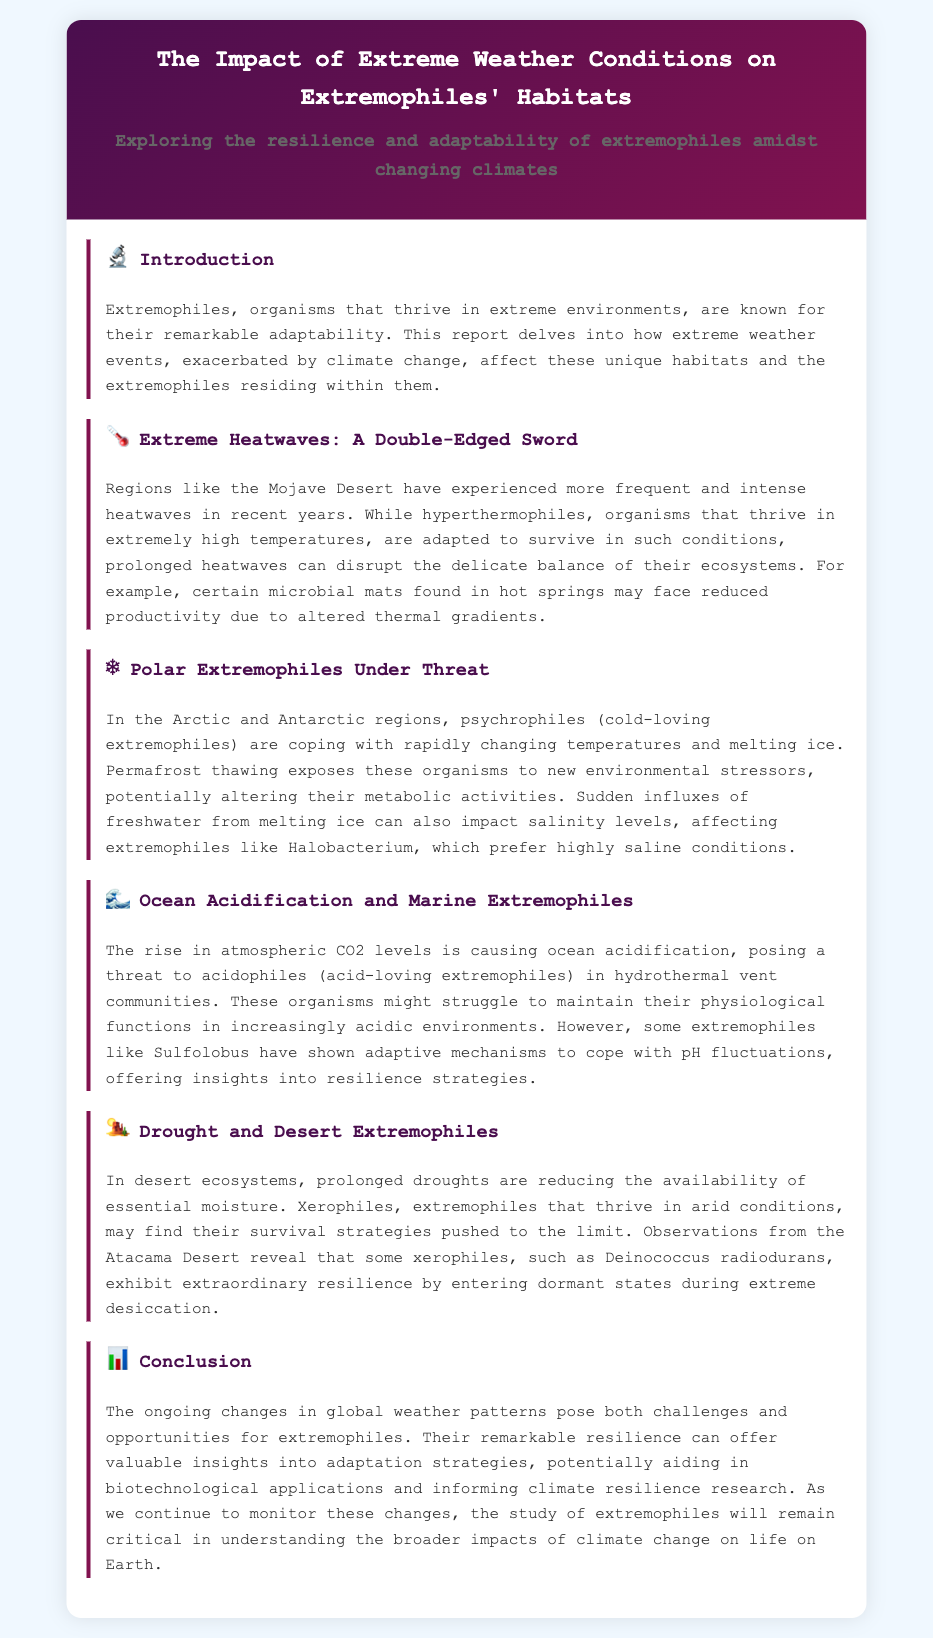What are extremophiles? The document defines extremophiles as organisms that thrive in extreme environments, highlighting their remarkable adaptability.
Answer: Organisms that thrive in extreme environments What conditions do hyperthermophiles thrive in? The report mentions that hyperthermophiles thrive in extremely high temperatures, specifically referencing the Mojave Desert.
Answer: Extremely high temperatures What are psychrophiles? The document describes psychrophiles as cold-loving extremophiles found in the Arctic and Antarctic regions.
Answer: Cold-loving extremophiles What threat does ocean acidification pose to acidophiles? The report states that ocean acidification threatens acidophiles in hydrothermal vent communities, affecting their physiological functions.
Answer: Affects their physiological functions What is an example of a xerophile mentioned in the report? The document provides an example of a xerophile as Deinococcus radiodurans, which exhibits resilience during extreme desiccation.
Answer: Deinococcus radiodurans How do extremophiles respond to extreme drought? The report explains that some xerophiles, like Deinococcus radiodurans, enter dormant states during extreme desiccation as a survival strategy.
Answer: Enter dormant states What is the potential application of studying extremophiles? The document mentions that studying extremophiles can aid in biotechnological applications and inform climate resilience research.
Answer: Biotechnological applications Which region is associated with the observed increasing trend of extreme heatwaves? The document specifically notes the Mojave Desert as a region experiencing more frequent and intense heatwaves.
Answer: Mojave Desert What type of organism is Halobacterium? The report states that Halobacterium is an extremophile that prefers highly saline conditions, especially vulnerable to freshwater influxes.
Answer: Extremophile that prefers highly saline conditions 